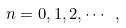Convert formula to latex. <formula><loc_0><loc_0><loc_500><loc_500>n = 0 , 1 , 2 , \cdots \ ,</formula> 